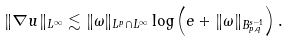<formula> <loc_0><loc_0><loc_500><loc_500>\| \nabla u \| _ { L ^ { \infty } } \lesssim \| \omega \| _ { L ^ { p } \cap L ^ { \infty } } \log \left ( e + \| \omega \| _ { B ^ { s - 1 } _ { p , q } } \right ) .</formula> 